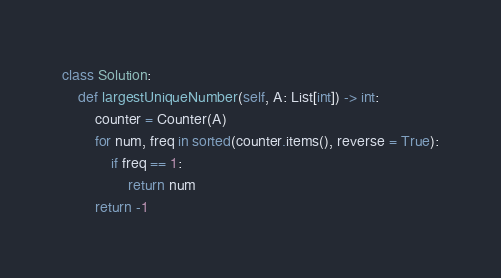<code> <loc_0><loc_0><loc_500><loc_500><_Python_>class Solution:
    def largestUniqueNumber(self, A: List[int]) -> int:
        counter = Counter(A)
        for num, freq in sorted(counter.items(), reverse = True):
            if freq == 1:
                return num
        return -1</code> 